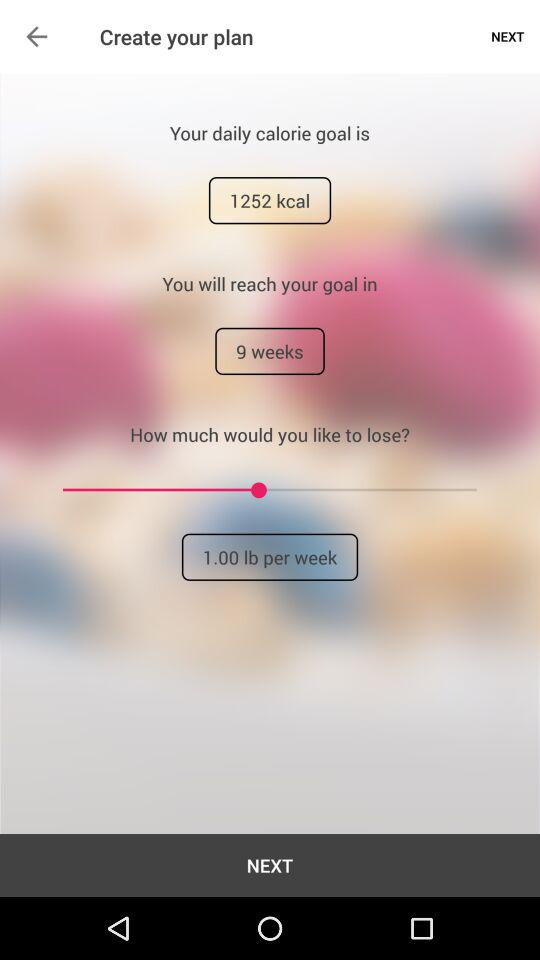What is the time limit for achieving my goal? The time limit for achieving your goal is 9 weeks. 